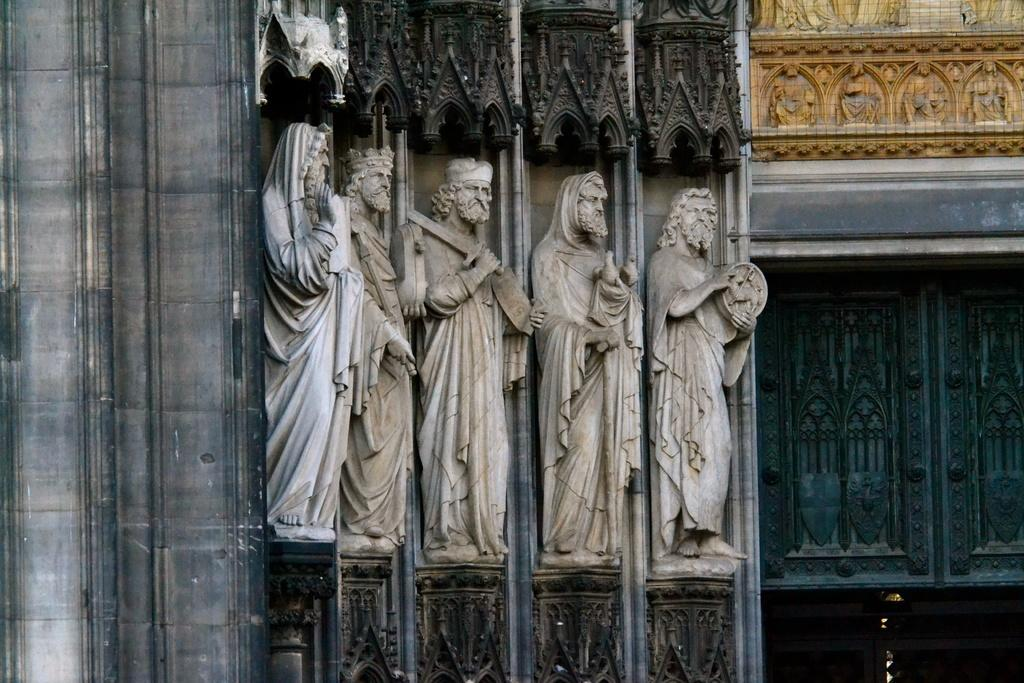What type of objects can be seen in the image? There are statues in the image. What architectural features are visible in the image? There are windows and buildings in the image. How many pizzas are being held by the statues in the image? There are no pizzas present in the image; the statues do not hold any objects. 